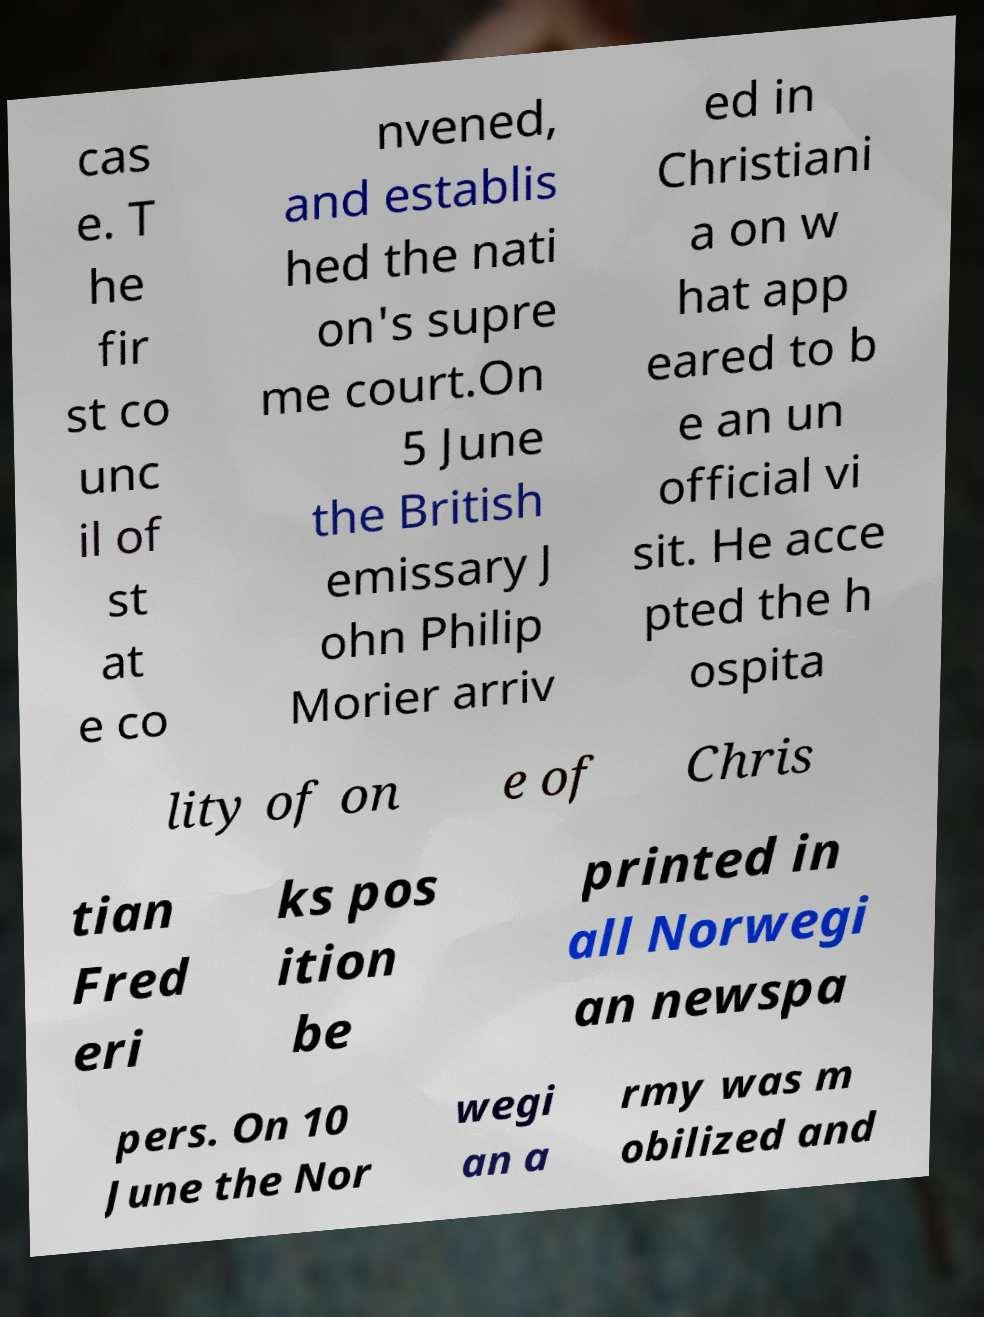For documentation purposes, I need the text within this image transcribed. Could you provide that? cas e. T he fir st co unc il of st at e co nvened, and establis hed the nati on's supre me court.On 5 June the British emissary J ohn Philip Morier arriv ed in Christiani a on w hat app eared to b e an un official vi sit. He acce pted the h ospita lity of on e of Chris tian Fred eri ks pos ition be printed in all Norwegi an newspa pers. On 10 June the Nor wegi an a rmy was m obilized and 